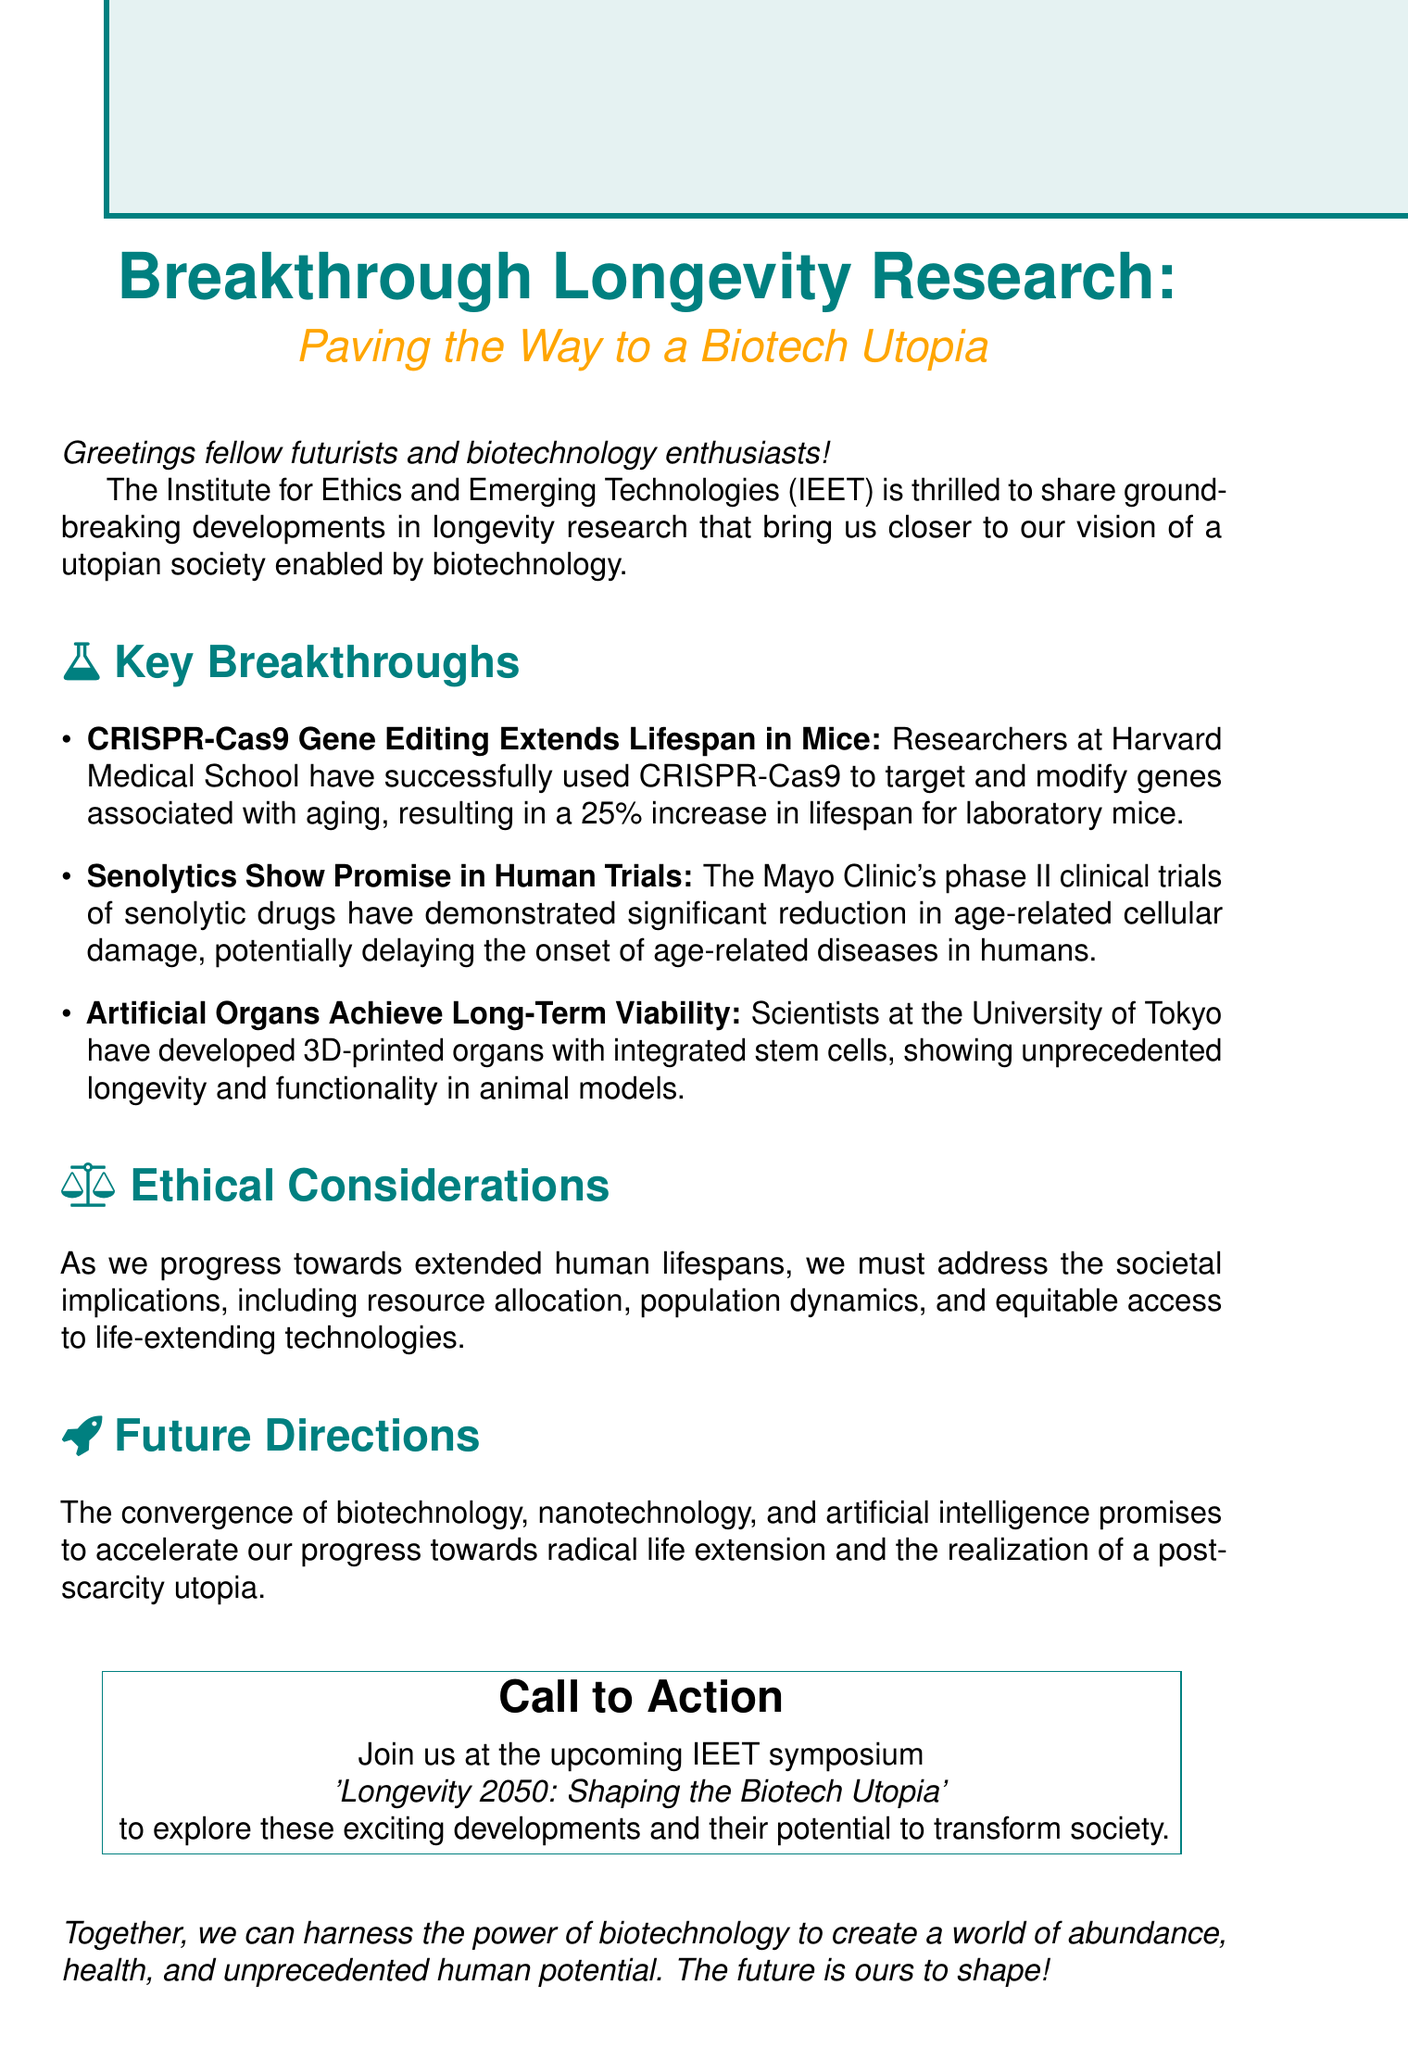what is the subject of the email? The subject provides the main topic of the email, which is stated at the top of the document.
Answer: Breakthrough Longevity Research: Paving the Way to a Biotech Utopia who conducted the CRISPR-Cas9 research? The document specifies the institution where the CRISPR-Cas9 research was conducted under the key breakthroughs section.
Answer: Harvard Medical School what percentage increase in lifespan was achieved in mice? The document provides a specific figure related to the research findings on lifespan extension in mice.
Answer: 25% what are senolytic drugs associated with? The document mentions the purpose of senolytic drugs in its description of the key breakthroughs.
Answer: Age-related diseases which university developed 3D-printed organs? The document explicitly states the university responsible for the research on 3D-printed organs.
Answer: University of Tokyo what societal implications must be addressed according to the email? The email outlines potential societal concerns that arise from extended human lifespans.
Answer: Resource allocation, population dynamics, and equitable access what is the name of the upcoming symposium? The document includes the title of the symposium in the call to action section.
Answer: Longevity 2050: Shaping the Biotech Utopia what is the main purpose of biotechnology according to the closing? The closing section emphasizes the intended outcome of biotechnology as it relates to societal transformation.
Answer: World of abundance, health, and unprecedented human potential 